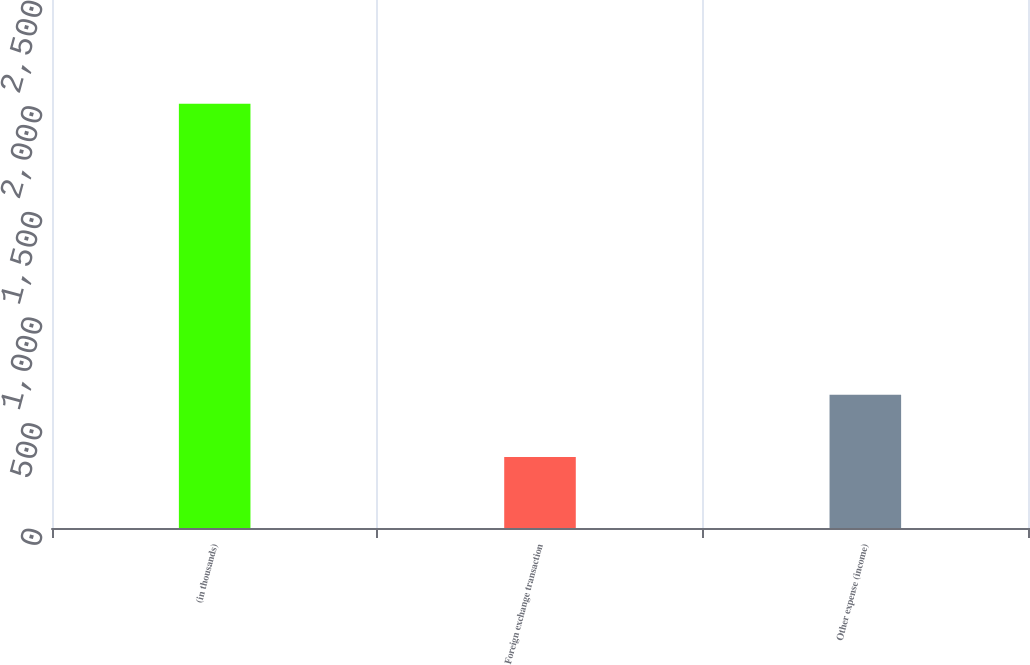Convert chart. <chart><loc_0><loc_0><loc_500><loc_500><bar_chart><fcel>(in thousands)<fcel>Foreign exchange transaction<fcel>Other expense (income)<nl><fcel>2009<fcel>336<fcel>631<nl></chart> 